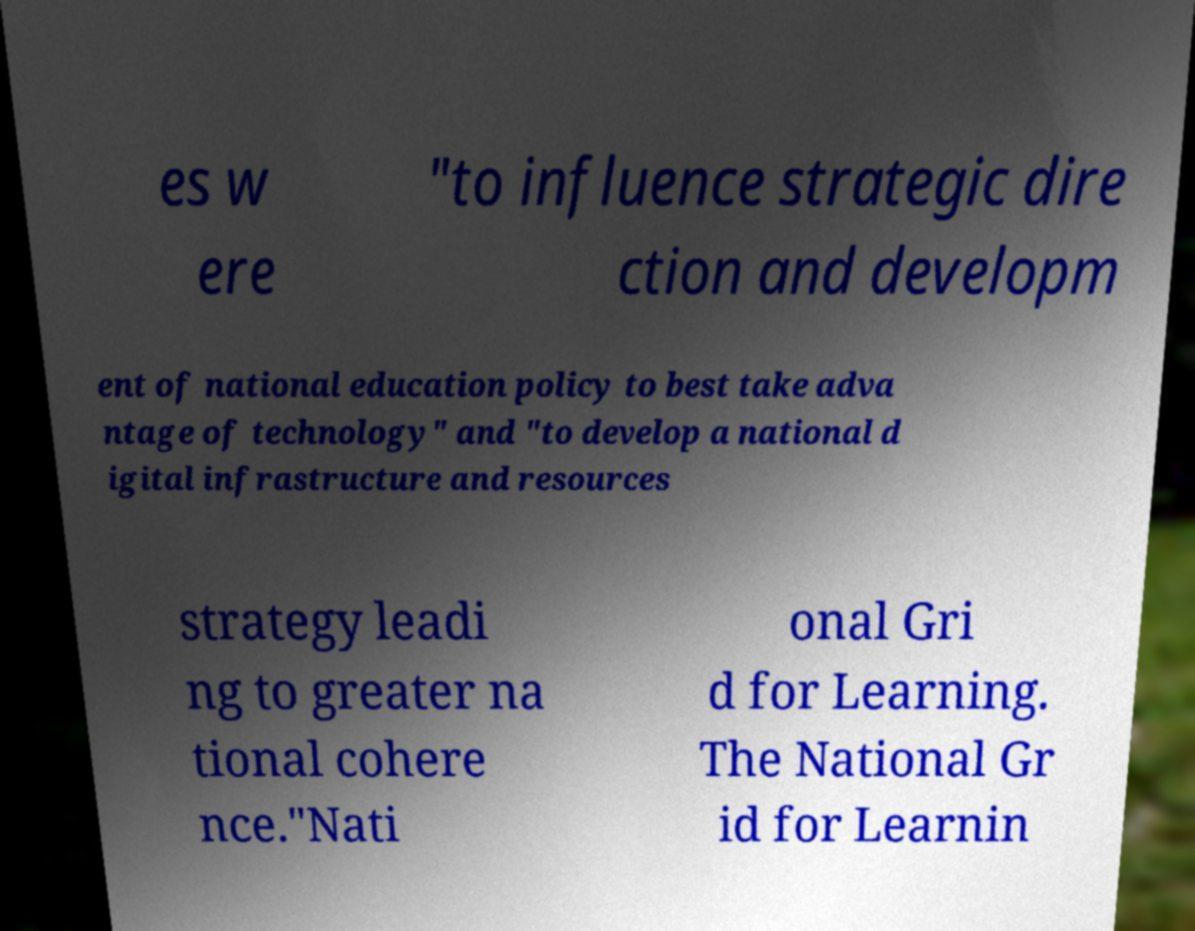Could you assist in decoding the text presented in this image and type it out clearly? es w ere "to influence strategic dire ction and developm ent of national education policy to best take adva ntage of technology" and "to develop a national d igital infrastructure and resources strategy leadi ng to greater na tional cohere nce."Nati onal Gri d for Learning. The National Gr id for Learnin 